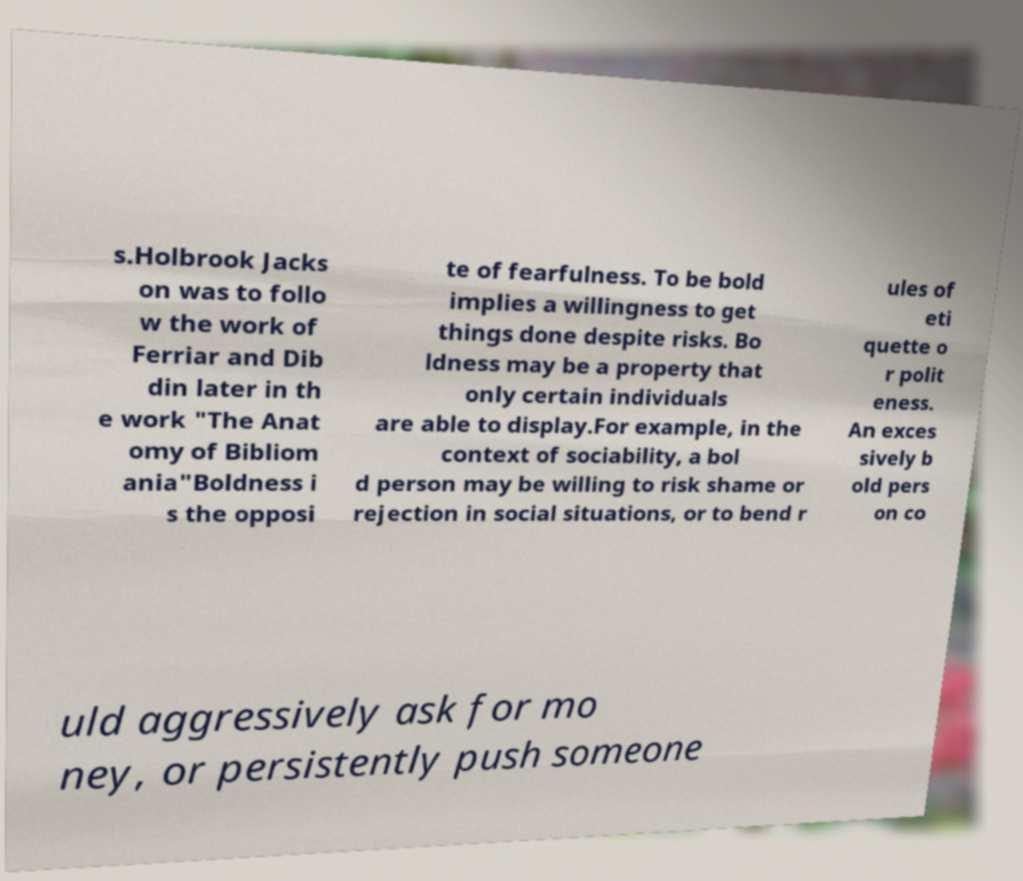Please identify and transcribe the text found in this image. s.Holbrook Jacks on was to follo w the work of Ferriar and Dib din later in th e work "The Anat omy of Bibliom ania"Boldness i s the opposi te of fearfulness. To be bold implies a willingness to get things done despite risks. Bo ldness may be a property that only certain individuals are able to display.For example, in the context of sociability, a bol d person may be willing to risk shame or rejection in social situations, or to bend r ules of eti quette o r polit eness. An exces sively b old pers on co uld aggressively ask for mo ney, or persistently push someone 